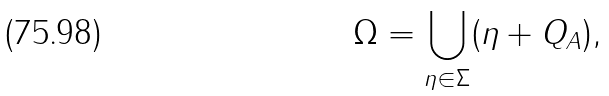Convert formula to latex. <formula><loc_0><loc_0><loc_500><loc_500>\Omega = \bigcup _ { \eta \in \Sigma } ( \eta + Q _ { A } ) ,</formula> 